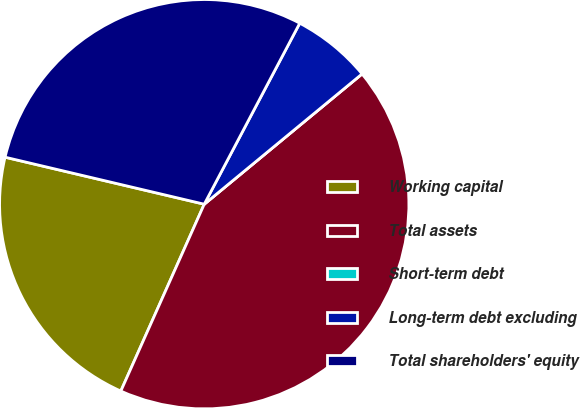Convert chart. <chart><loc_0><loc_0><loc_500><loc_500><pie_chart><fcel>Working capital<fcel>Total assets<fcel>Short-term debt<fcel>Long-term debt excluding<fcel>Total shareholders' equity<nl><fcel>22.01%<fcel>42.67%<fcel>0.0%<fcel>6.29%<fcel>29.04%<nl></chart> 